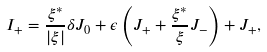<formula> <loc_0><loc_0><loc_500><loc_500>I _ { + } = \frac { \xi ^ { * } } { | \xi | } \delta J _ { 0 } + \epsilon \left ( J _ { + } + \frac { \xi ^ { * } } { \xi } J _ { - } \right ) + J _ { + } ,</formula> 